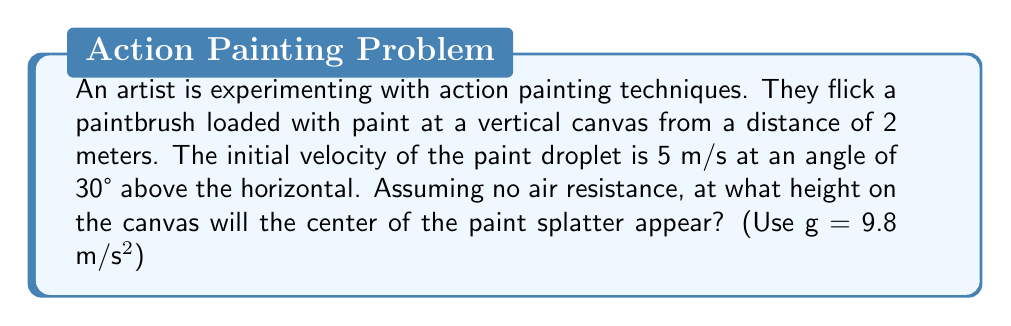Help me with this question. To solve this problem, we'll use the equations of projectile motion:

1) Horizontal motion: $x = v_0 \cos(\theta) \cdot t$
2) Vertical motion: $y = v_0 \sin(\theta) \cdot t - \frac{1}{2}gt^2$

Where:
$v_0 = 5$ m/s (initial velocity)
$\theta = 30°$ (angle above horizontal)
$g = 9.8$ m/s² (acceleration due to gravity)

Step 1: Calculate the time it takes for the paint to reach the canvas.
Using the horizontal motion equation:
$2 = 5 \cos(30°) \cdot t$
$t = \frac{2}{5 \cos(30°)} \approx 0.4619$ seconds

Step 2: Use this time to calculate the vertical displacement.
$y = 5 \sin(30°) \cdot 0.4619 - \frac{1}{2}(9.8)(0.4619)^2$

Step 3: Simplify and calculate:
$y = 5 \cdot 0.5 \cdot 0.4619 - \frac{1}{2}(9.8)(0.2134)$
$y = 1.1548 - 1.0456$
$y \approx 0.1092$ meters

Therefore, the paint splatter will appear approximately 0.1092 meters (10.92 cm) above the initial height of the paintbrush.
Answer: 10.92 cm 